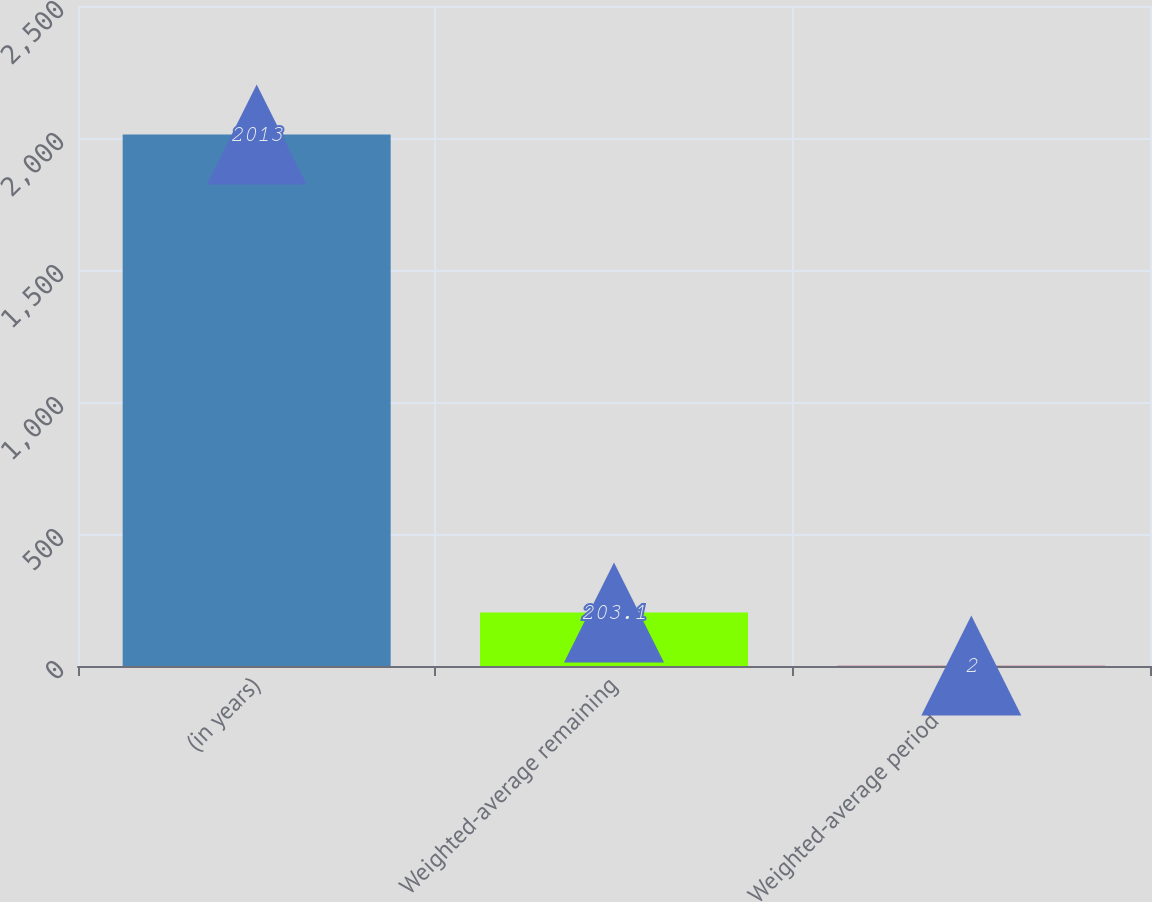Convert chart to OTSL. <chart><loc_0><loc_0><loc_500><loc_500><bar_chart><fcel>(in years)<fcel>Weighted-average remaining<fcel>Weighted-average period over<nl><fcel>2013<fcel>203.1<fcel>2<nl></chart> 